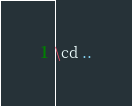<code> <loc_0><loc_0><loc_500><loc_500><_SQL_>\cd ..

</code> 